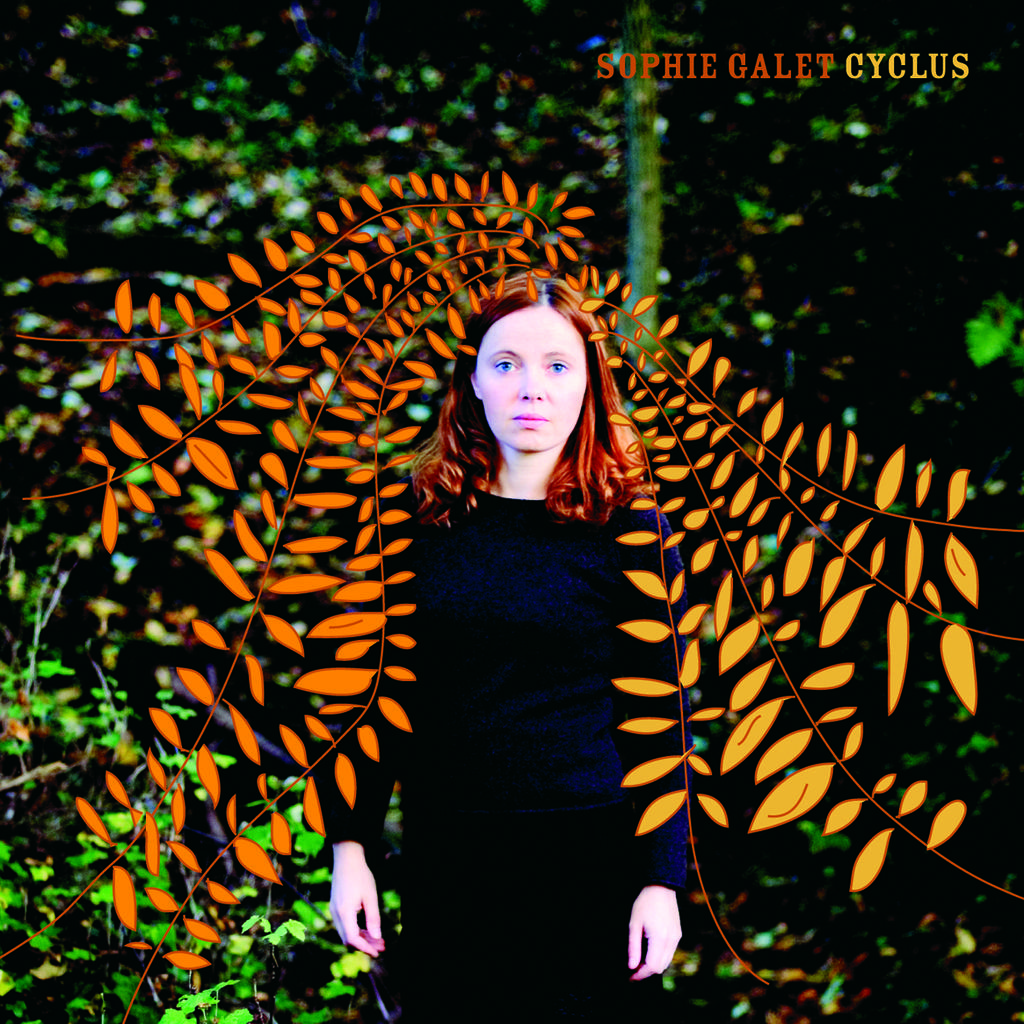Who is the main subject in the image? There is a girl in the image. What is the girl doing in the image? A: The girl is standing. What is the girl wearing in the image? The girl is wearing a black dress. What can be seen on the left side of the image? There are leaves of a plant on the left side of the image. What language is the girl speaking in the image? The image does not provide any information about the language being spoken, as it is a visual medium and does not include audio. Can you tell me what type of fruit is hanging from the plant on the left side of the image? There is no fruit visible in the image; only leaves of a plant are present on the left side. 